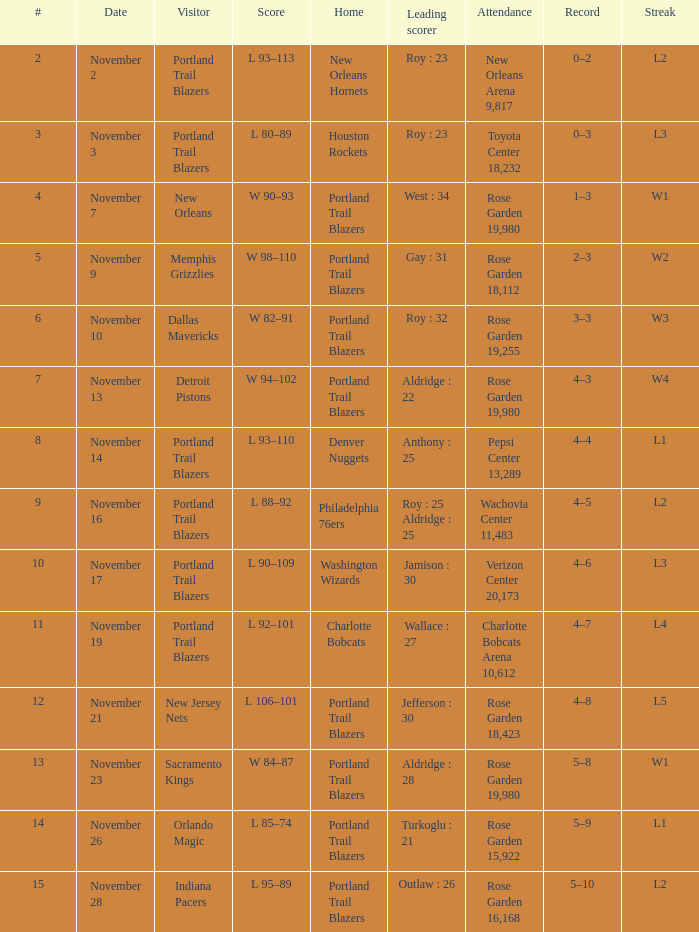What's the presence where the score is between 92-101? Charlotte Bobcats Arena 10,612. 